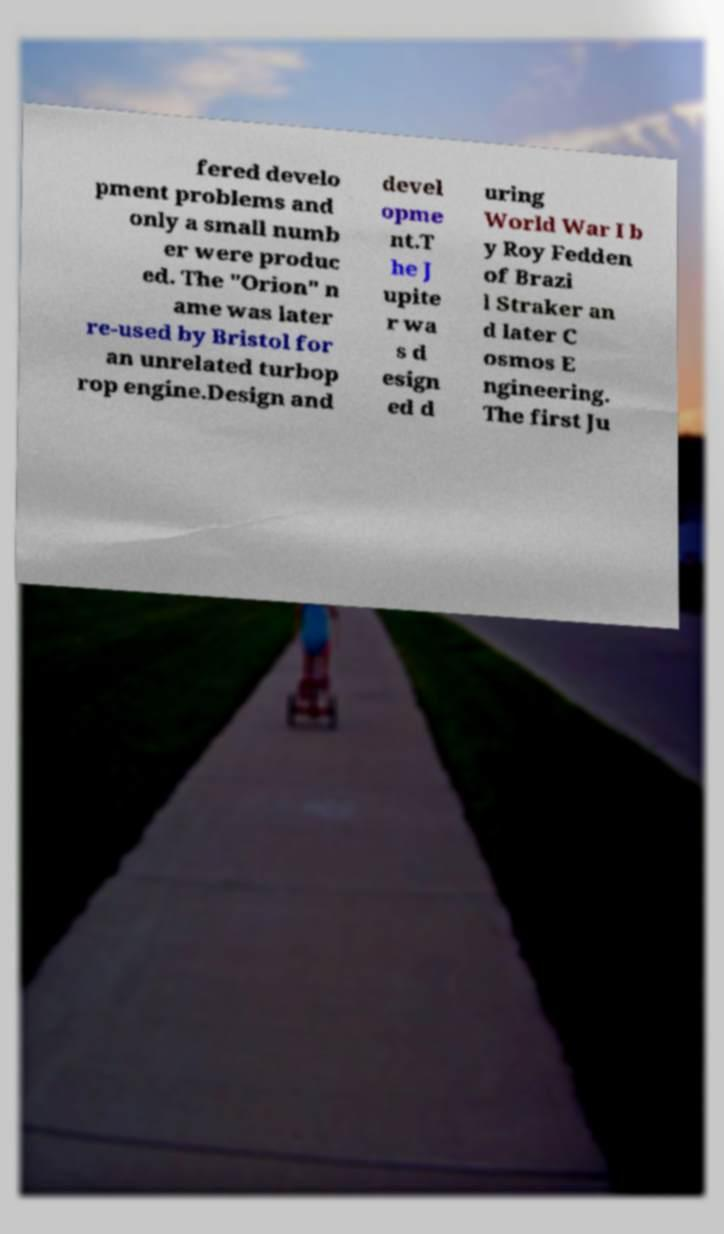Please identify and transcribe the text found in this image. fered develo pment problems and only a small numb er were produc ed. The "Orion" n ame was later re-used by Bristol for an unrelated turbop rop engine.Design and devel opme nt.T he J upite r wa s d esign ed d uring World War I b y Roy Fedden of Brazi l Straker an d later C osmos E ngineering. The first Ju 